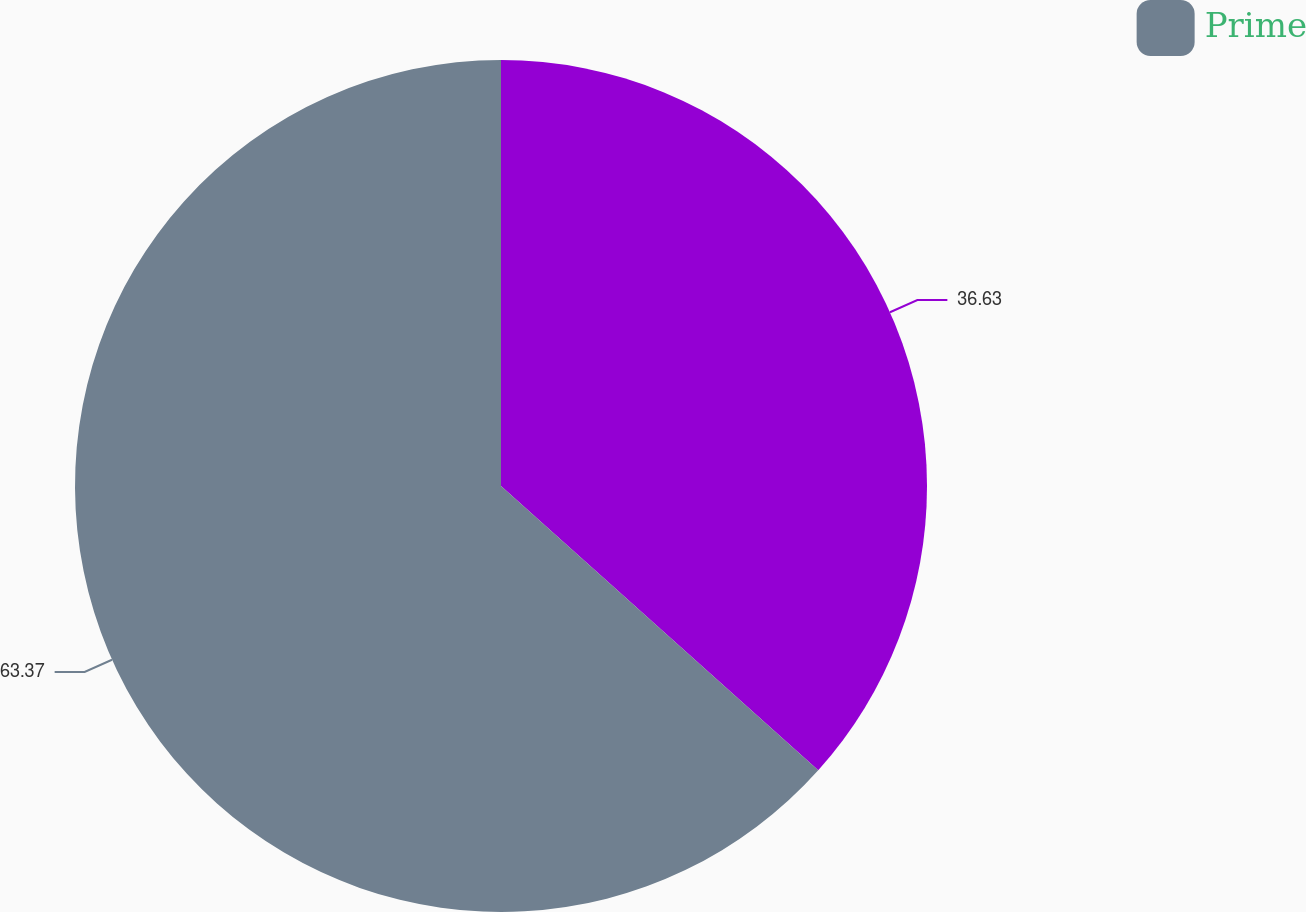Convert chart to OTSL. <chart><loc_0><loc_0><loc_500><loc_500><pie_chart><ecel><fcel>Prime<nl><fcel>36.63%<fcel>63.37%<nl></chart> 